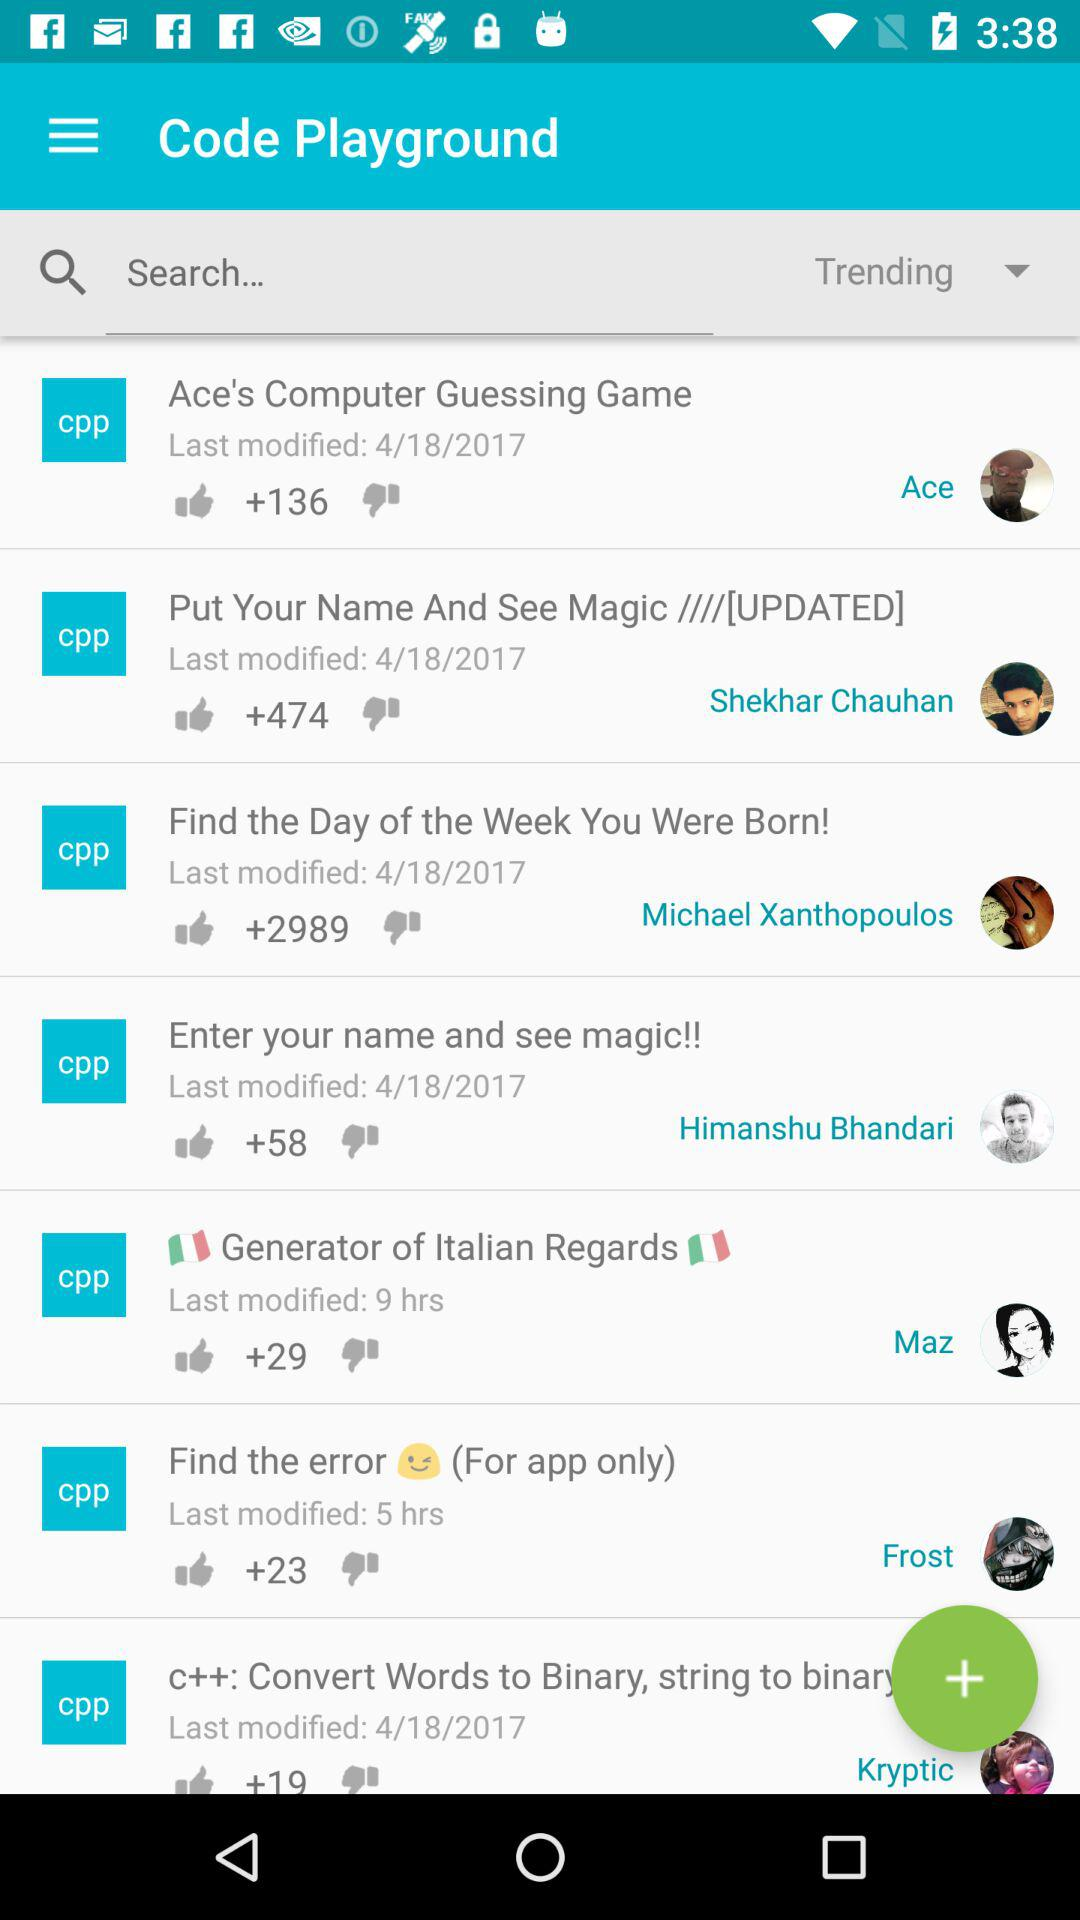Can you tell me more about the kind of projects listed in this image? Sure, the projects listed in the image are varied in nature. They include a computer guessing game, a personalized magic display using your name, a program to find out the day of the week you were born, and a utility that generates Italian greetings. These projects seem to be user-contributed and cover the realms of games, personalized scripts, and utilities, showcasing the creativity and programming skills of their respective creators. 